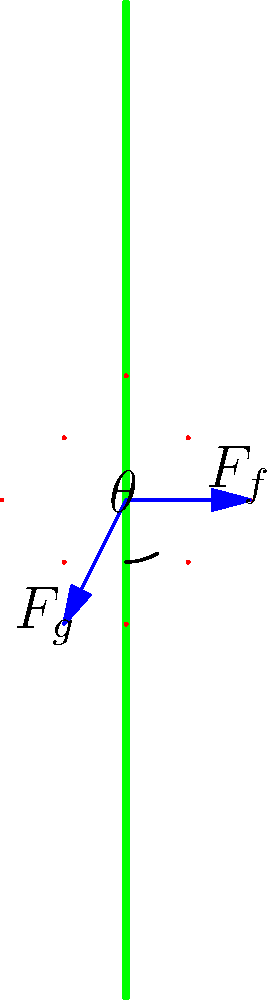In the biomechanics of climbing a coconut tree, what is the relationship between the friction force ($F_f$) and the climber's weight ($F_g$) at the point where the climber is just about to slip? Express your answer in terms of the coefficient of static friction ($\mu_s$) and the angle ($\theta$) between the tree and the vertical. To solve this problem, let's follow these steps:

1. Identify the forces: The two main forces acting on the climber are the friction force ($F_f$) and the gravitational force ($F_g$).

2. Resolve forces: We need to consider the components of these forces parallel and perpendicular to the tree surface.

3. For equilibrium, the sum of forces parallel to the tree surface must be zero:
   $F_f - F_g \sin\theta = 0$

4. The normal force ($N$) is equal to the component of weight perpendicular to the tree surface:
   $N = F_g \cos\theta$

5. At the point of impending slip, the friction force is at its maximum value:
   $F_f = \mu_s N = \mu_s F_g \cos\theta$

6. Substituting this into the equilibrium equation:
   $\mu_s F_g \cos\theta - F_g \sin\theta = 0$

7. Simplify:
   $\mu_s \cos\theta = \sin\theta$

8. Rearrange to express $\mu_s$ in terms of $\theta$:
   $\mu_s = \frac{\sin\theta}{\cos\theta} = \tan\theta$

Therefore, at the point of impending slip, the coefficient of static friction is equal to the tangent of the angle between the tree and the vertical.
Answer: $\mu_s = \tan\theta$ 